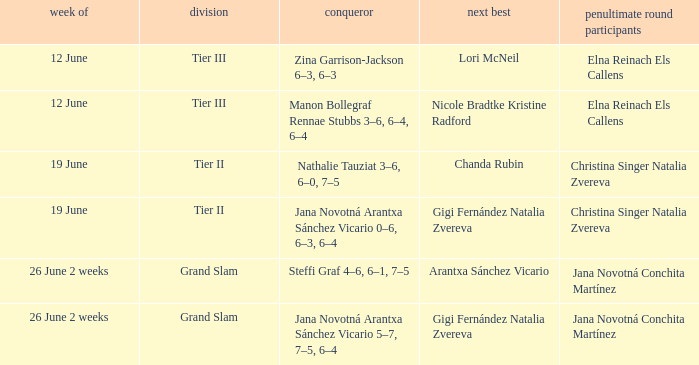In which week does the record show jana novotná arantxa sánchez vicario as the winner with a score of 5-7, 7-5, 6-4? 26 June 2 weeks. Parse the table in full. {'header': ['week of', 'division', 'conqueror', 'next best', 'penultimate round participants'], 'rows': [['12 June', 'Tier III', 'Zina Garrison-Jackson 6–3, 6–3', 'Lori McNeil', 'Elna Reinach Els Callens'], ['12 June', 'Tier III', 'Manon Bollegraf Rennae Stubbs 3–6, 6–4, 6–4', 'Nicole Bradtke Kristine Radford', 'Elna Reinach Els Callens'], ['19 June', 'Tier II', 'Nathalie Tauziat 3–6, 6–0, 7–5', 'Chanda Rubin', 'Christina Singer Natalia Zvereva'], ['19 June', 'Tier II', 'Jana Novotná Arantxa Sánchez Vicario 0–6, 6–3, 6–4', 'Gigi Fernández Natalia Zvereva', 'Christina Singer Natalia Zvereva'], ['26 June 2 weeks', 'Grand Slam', 'Steffi Graf 4–6, 6–1, 7–5', 'Arantxa Sánchez Vicario', 'Jana Novotná Conchita Martínez'], ['26 June 2 weeks', 'Grand Slam', 'Jana Novotná Arantxa Sánchez Vicario 5–7, 7–5, 6–4', 'Gigi Fernández Natalia Zvereva', 'Jana Novotná Conchita Martínez']]} 